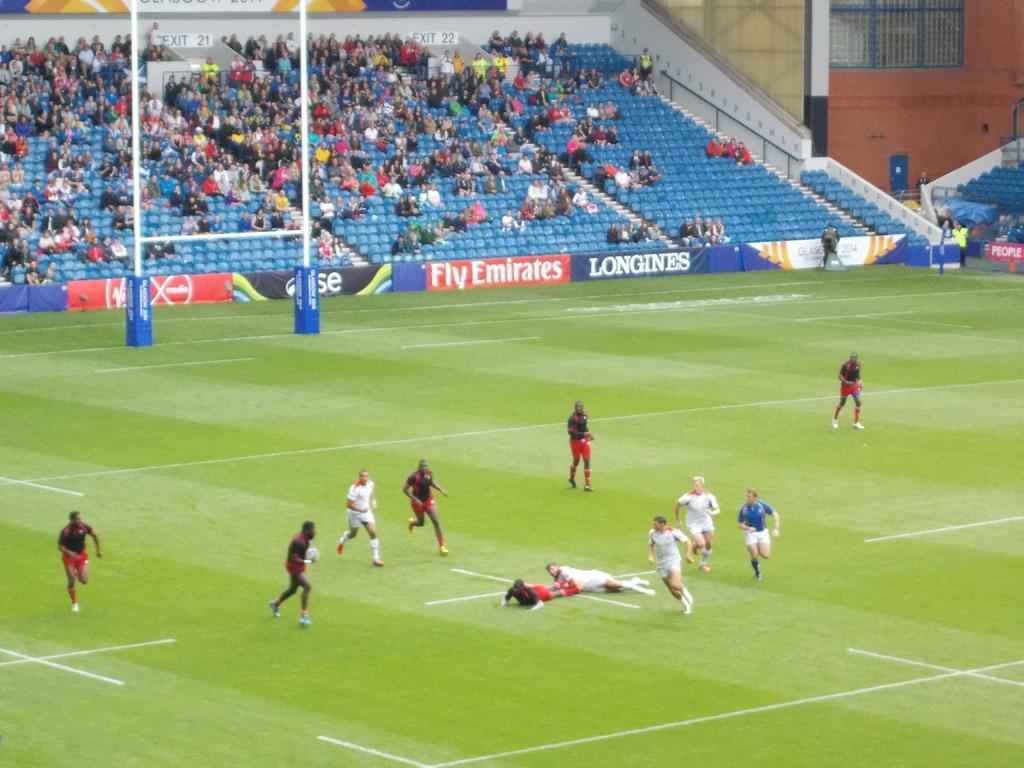How would you summarize this image in a sentence or two? This is a soccer stadium. People are playing soccer game. In the background there are audience sitting on the chair and poles and hoardings. 